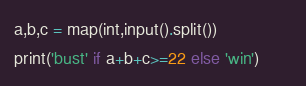Convert code to text. <code><loc_0><loc_0><loc_500><loc_500><_Python_>a,b,c = map(int,input().split())
print('bust' if a+b+c>=22 else 'win')       </code> 